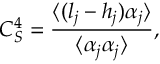<formula> <loc_0><loc_0><loc_500><loc_500>C _ { S } ^ { 4 } = \frac { \langle ( l _ { j } - h _ { j } ) \alpha _ { j } \rangle } { \langle \alpha _ { j } \alpha _ { j } \rangle } ,</formula> 